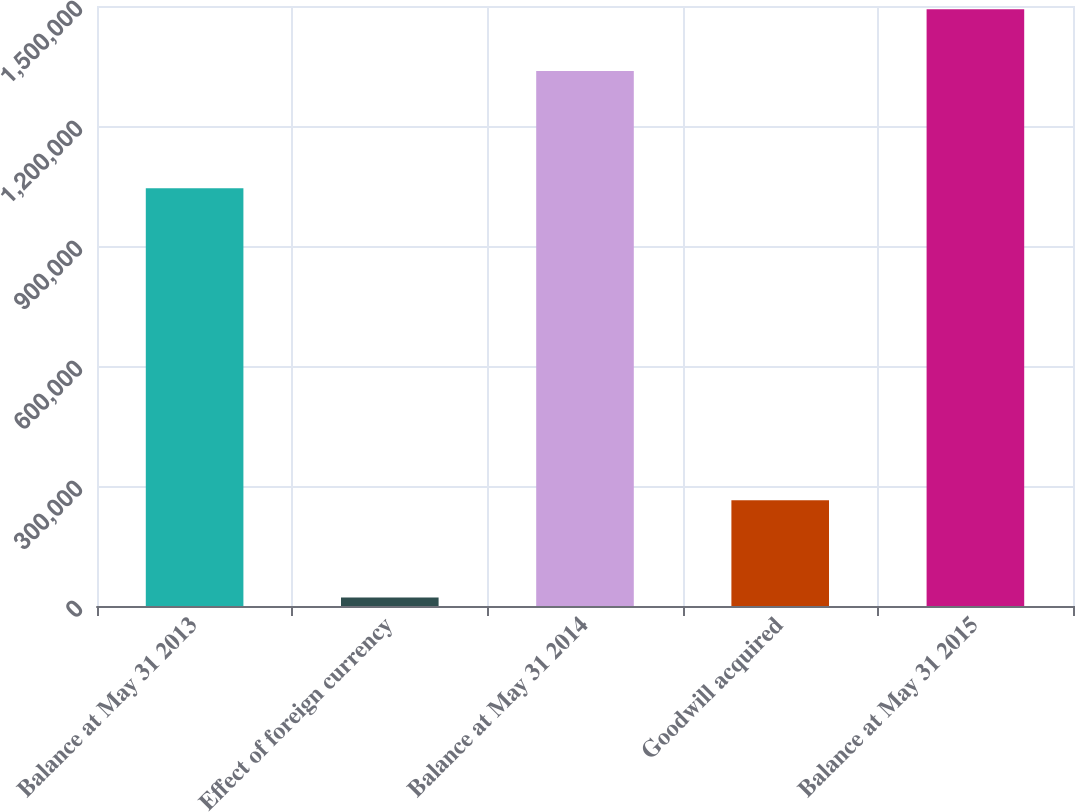<chart> <loc_0><loc_0><loc_500><loc_500><bar_chart><fcel>Balance at May 31 2013<fcel>Effect of foreign currency<fcel>Balance at May 31 2014<fcel>Goodwill acquired<fcel>Balance at May 31 2015<nl><fcel>1.04422e+06<fcel>21486<fcel>1.33728e+06<fcel>264239<fcel>1.49183e+06<nl></chart> 